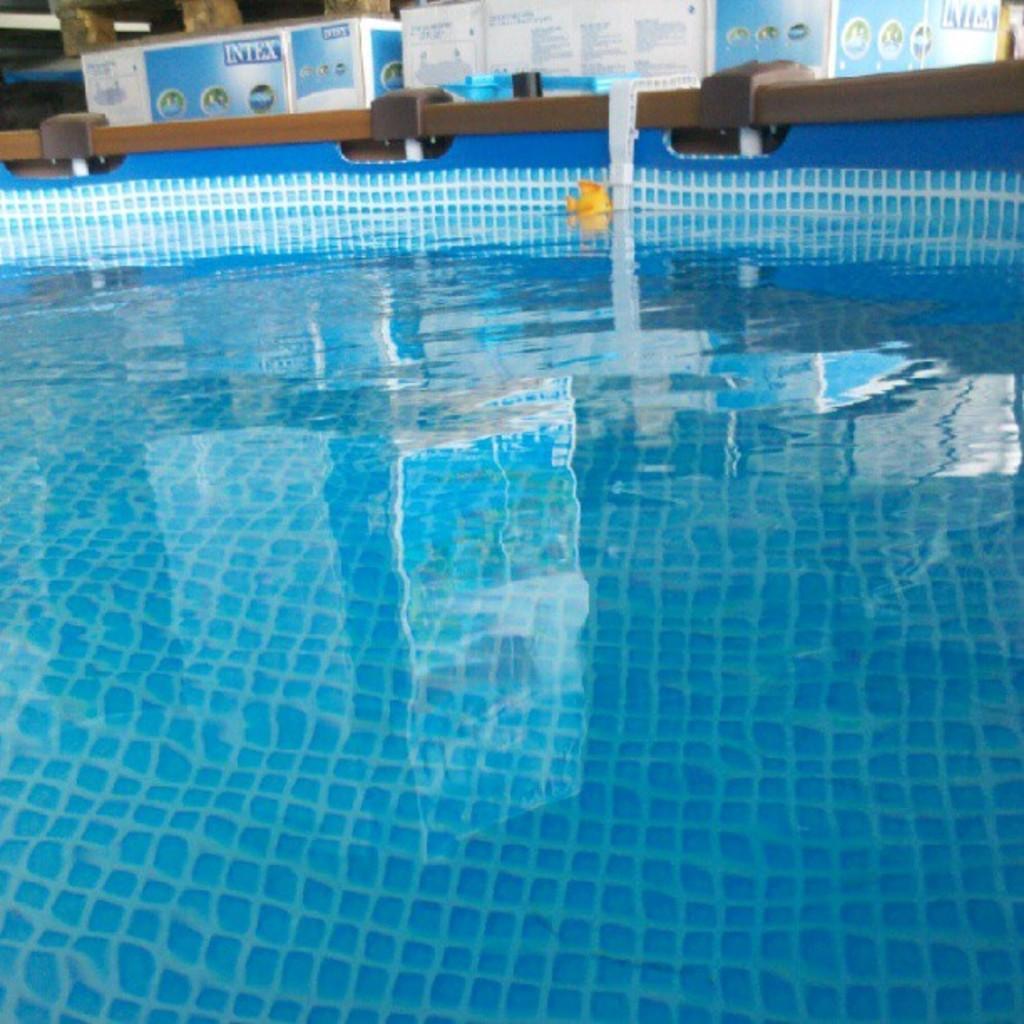In one or two sentences, can you explain what this image depicts? In this image, we can see a pool and in the background, there are some boxes. 